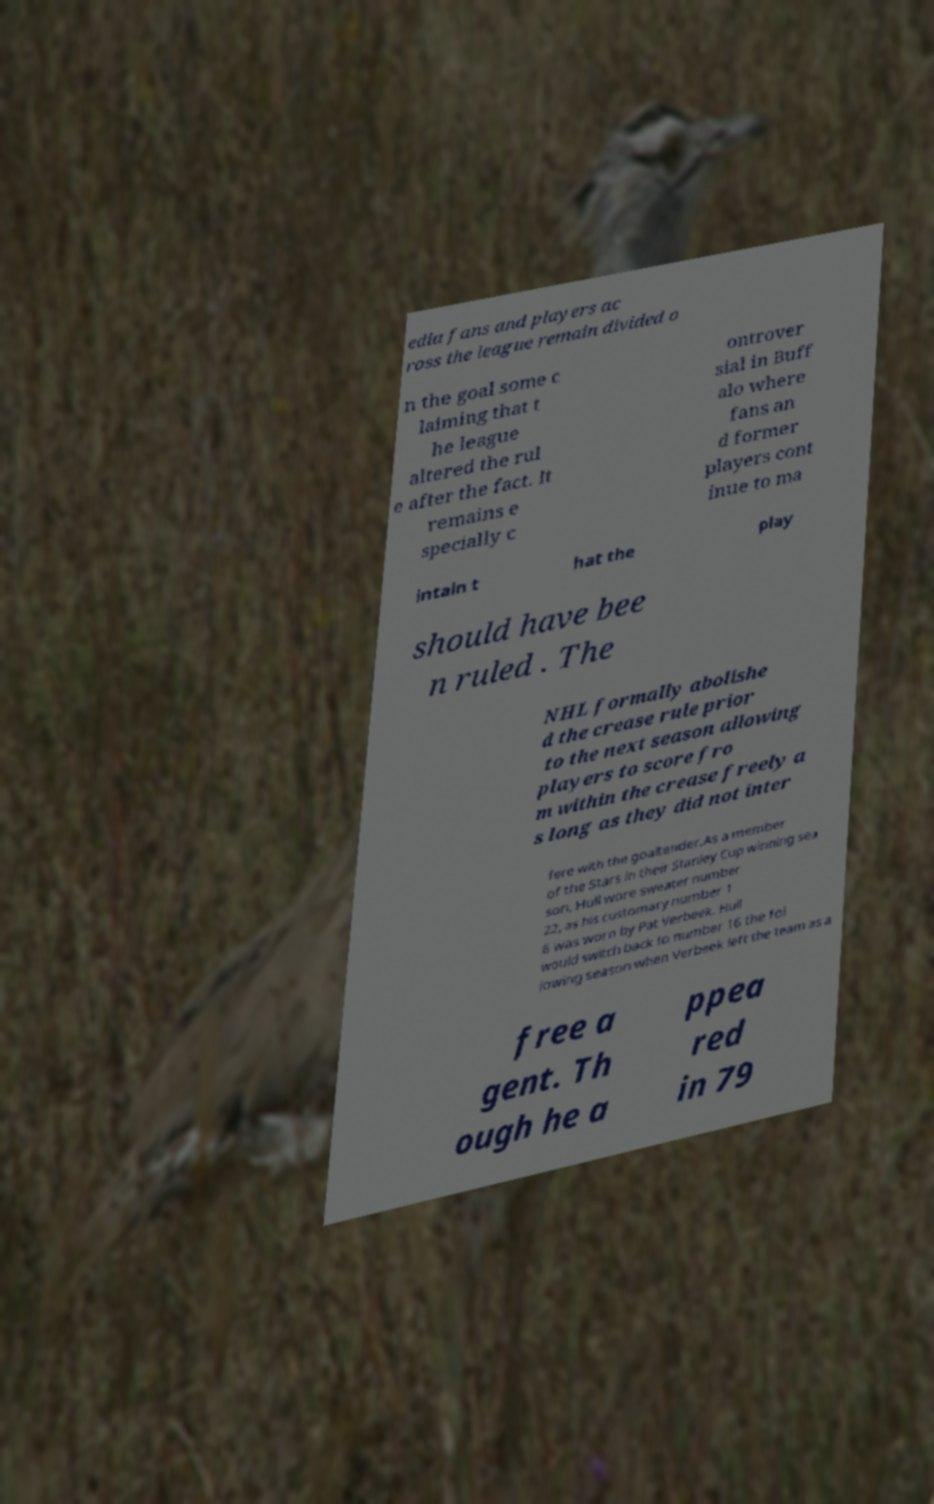Please read and relay the text visible in this image. What does it say? edia fans and players ac ross the league remain divided o n the goal some c laiming that t he league altered the rul e after the fact. It remains e specially c ontrover sial in Buff alo where fans an d former players cont inue to ma intain t hat the play should have bee n ruled . The NHL formally abolishe d the crease rule prior to the next season allowing players to score fro m within the crease freely a s long as they did not inter fere with the goaltender.As a member of the Stars in their Stanley Cup winning sea son, Hull wore sweater number 22, as his customary number 1 6 was worn by Pat Verbeek. Hull would switch back to number 16 the fol lowing season when Verbeek left the team as a free a gent. Th ough he a ppea red in 79 